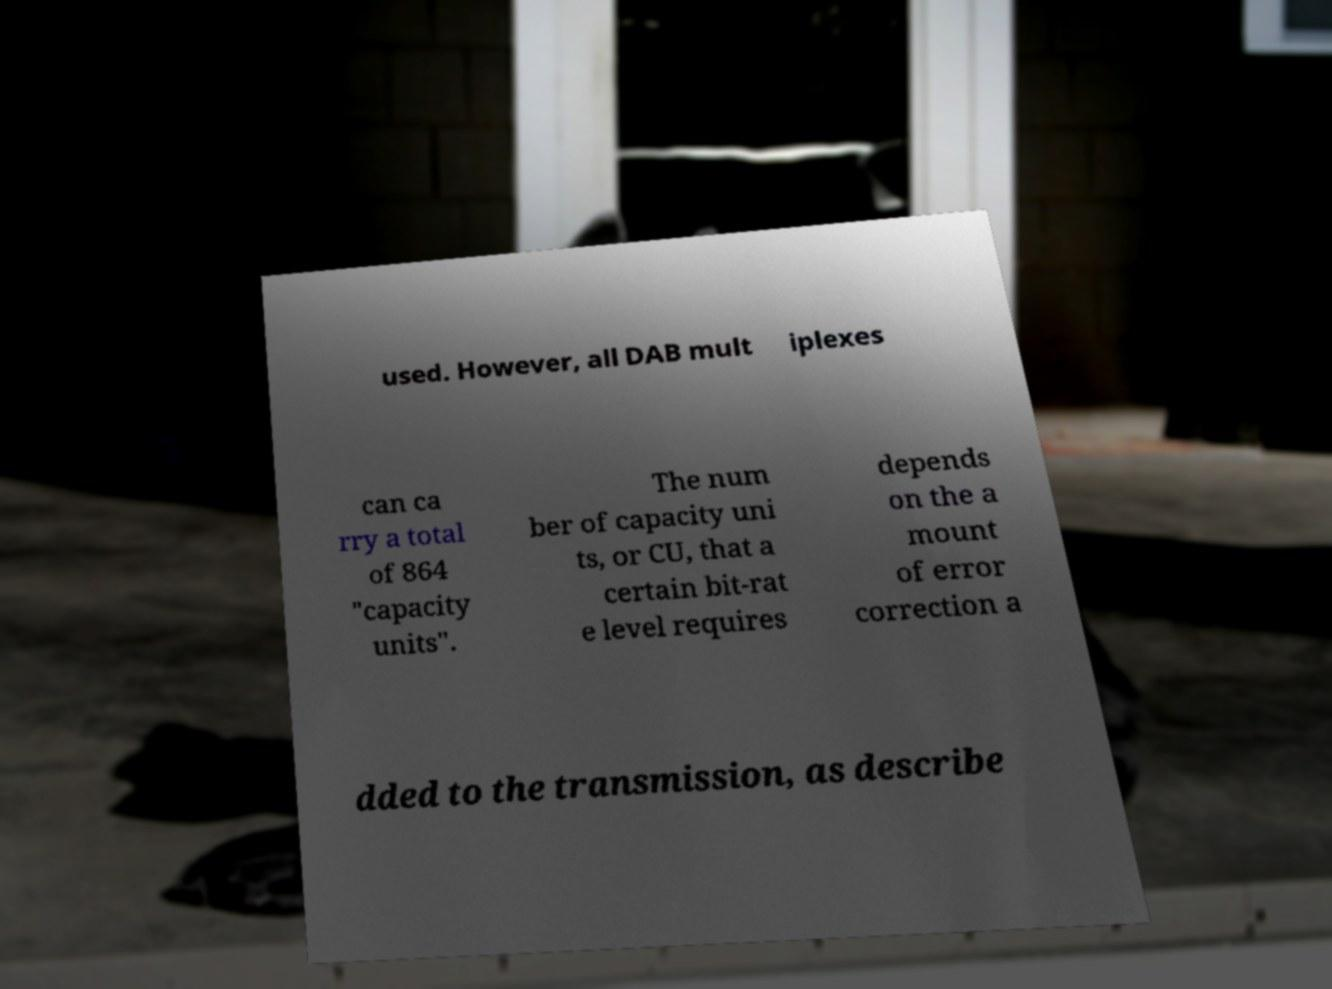Could you extract and type out the text from this image? used. However, all DAB mult iplexes can ca rry a total of 864 "capacity units". The num ber of capacity uni ts, or CU, that a certain bit-rat e level requires depends on the a mount of error correction a dded to the transmission, as describe 